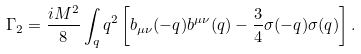Convert formula to latex. <formula><loc_0><loc_0><loc_500><loc_500>\Gamma _ { 2 } = \frac { i M ^ { 2 } } { 8 } \int _ { q } q ^ { 2 } \left [ b _ { \mu \nu } ( - q ) b ^ { \mu \nu } ( q ) - \frac { 3 } { 4 } \sigma ( - q ) \sigma ( q ) \right ] .</formula> 